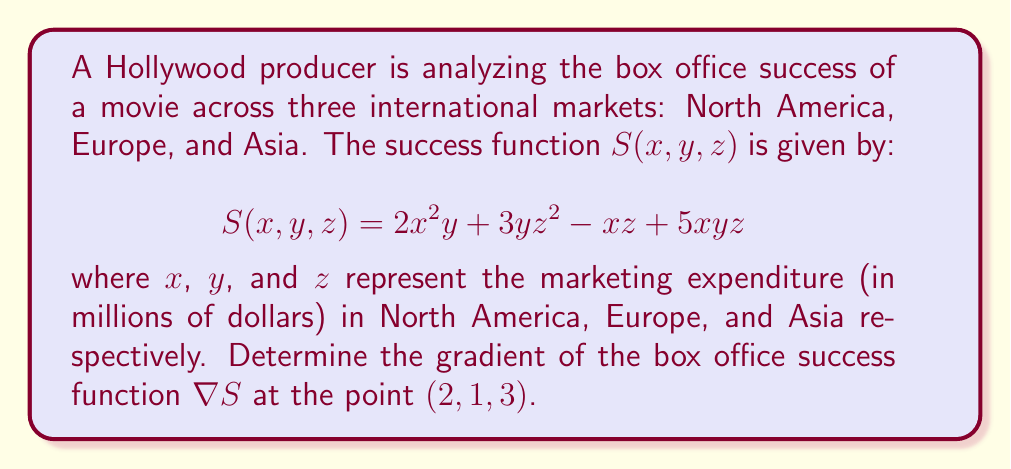Solve this math problem. To find the gradient of the box office success function, we need to calculate the partial derivatives with respect to each variable and evaluate them at the given point.

Step 1: Calculate $\frac{\partial S}{\partial x}$
$$\frac{\partial S}{\partial x} = 4xy + 5yz - z$$

Step 2: Calculate $\frac{\partial S}{\partial y}$
$$\frac{\partial S}{\partial y} = 2x^2 + 3z^2 + 5xz$$

Step 3: Calculate $\frac{\partial S}{\partial z}$
$$\frac{\partial S}{\partial z} = 6yz - x + 5xy$$

Step 4: Form the gradient vector
$$\nabla S = \left(\frac{\partial S}{\partial x}, \frac{\partial S}{\partial y}, \frac{\partial S}{\partial z}\right)$$

Step 5: Evaluate the gradient at the point $(2, 1, 3)$
$$\begin{aligned}
\frac{\partial S}{\partial x}(2, 1, 3) &= 4(2)(1) + 5(1)(3) - 3 = 20 \\
\frac{\partial S}{\partial y}(2, 1, 3) &= 2(2)^2 + 3(3)^2 + 5(2)(3) = 47 \\
\frac{\partial S}{\partial z}(2, 1, 3) &= 6(1)(3) - 2 + 5(2)(1) = 26
\end{aligned}$$

Therefore, the gradient at the point $(2, 1, 3)$ is:
$$\nabla S(2, 1, 3) = (20, 47, 26)$$
Answer: $(20, 47, 26)$ 